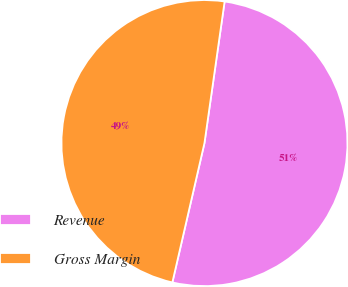Convert chart to OTSL. <chart><loc_0><loc_0><loc_500><loc_500><pie_chart><fcel>Revenue<fcel>Gross Margin<nl><fcel>51.35%<fcel>48.65%<nl></chart> 